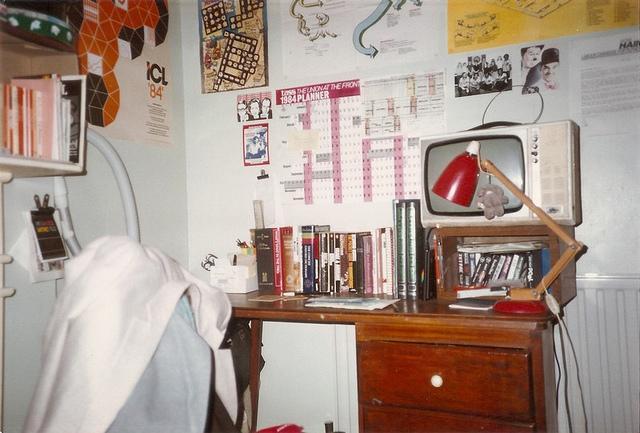How many books can you see?
Give a very brief answer. 2. How many elephants are walking down the street?
Give a very brief answer. 0. 